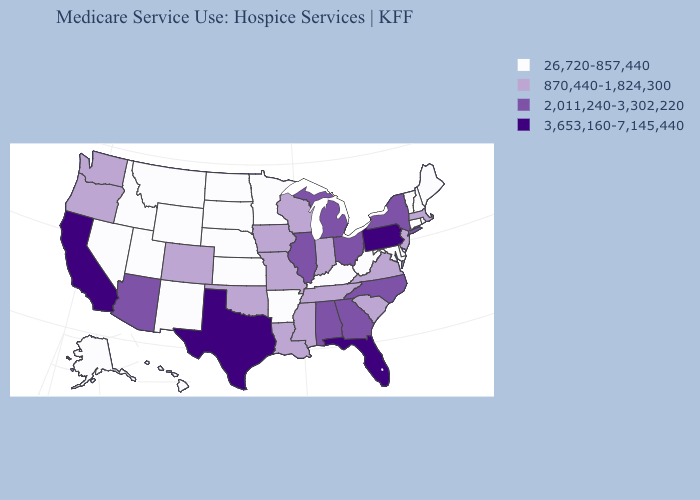Name the states that have a value in the range 26,720-857,440?
Short answer required. Alaska, Arkansas, Connecticut, Delaware, Hawaii, Idaho, Kansas, Kentucky, Maine, Maryland, Minnesota, Montana, Nebraska, Nevada, New Hampshire, New Mexico, North Dakota, Rhode Island, South Dakota, Utah, Vermont, West Virginia, Wyoming. What is the lowest value in states that border Missouri?
Short answer required. 26,720-857,440. Name the states that have a value in the range 870,440-1,824,300?
Concise answer only. Colorado, Indiana, Iowa, Louisiana, Massachusetts, Mississippi, Missouri, New Jersey, Oklahoma, Oregon, South Carolina, Tennessee, Virginia, Washington, Wisconsin. What is the value of New Jersey?
Give a very brief answer. 870,440-1,824,300. Does New York have the lowest value in the USA?
Short answer required. No. What is the value of Maryland?
Give a very brief answer. 26,720-857,440. Name the states that have a value in the range 2,011,240-3,302,220?
Answer briefly. Alabama, Arizona, Georgia, Illinois, Michigan, New York, North Carolina, Ohio. Which states have the highest value in the USA?
Quick response, please. California, Florida, Pennsylvania, Texas. Name the states that have a value in the range 870,440-1,824,300?
Write a very short answer. Colorado, Indiana, Iowa, Louisiana, Massachusetts, Mississippi, Missouri, New Jersey, Oklahoma, Oregon, South Carolina, Tennessee, Virginia, Washington, Wisconsin. Name the states that have a value in the range 3,653,160-7,145,440?
Concise answer only. California, Florida, Pennsylvania, Texas. Name the states that have a value in the range 870,440-1,824,300?
Be succinct. Colorado, Indiana, Iowa, Louisiana, Massachusetts, Mississippi, Missouri, New Jersey, Oklahoma, Oregon, South Carolina, Tennessee, Virginia, Washington, Wisconsin. Name the states that have a value in the range 26,720-857,440?
Concise answer only. Alaska, Arkansas, Connecticut, Delaware, Hawaii, Idaho, Kansas, Kentucky, Maine, Maryland, Minnesota, Montana, Nebraska, Nevada, New Hampshire, New Mexico, North Dakota, Rhode Island, South Dakota, Utah, Vermont, West Virginia, Wyoming. Does Georgia have the same value as Colorado?
Give a very brief answer. No. How many symbols are there in the legend?
Give a very brief answer. 4. Name the states that have a value in the range 26,720-857,440?
Quick response, please. Alaska, Arkansas, Connecticut, Delaware, Hawaii, Idaho, Kansas, Kentucky, Maine, Maryland, Minnesota, Montana, Nebraska, Nevada, New Hampshire, New Mexico, North Dakota, Rhode Island, South Dakota, Utah, Vermont, West Virginia, Wyoming. 